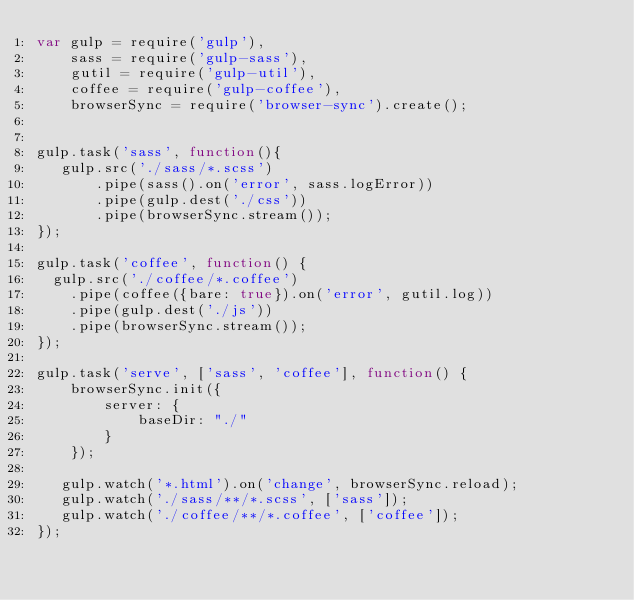<code> <loc_0><loc_0><loc_500><loc_500><_JavaScript_>var gulp = require('gulp'),
	sass = require('gulp-sass'),
	gutil = require('gulp-util'),
	coffee = require('gulp-coffee'),
	browserSync = require('browser-sync').create();


gulp.task('sass', function(){
   gulp.src('./sass/*.scss')
	   .pipe(sass().on('error', sass.logError))
	   .pipe(gulp.dest('./css'))
	   .pipe(browserSync.stream());
});

gulp.task('coffee', function() {
  gulp.src('./coffee/*.coffee')
    .pipe(coffee({bare: true}).on('error', gutil.log))
    .pipe(gulp.dest('./js'))
	.pipe(browserSync.stream());
});

gulp.task('serve', ['sass', 'coffee'], function() {
	browserSync.init({
		server: {
			baseDir: "./"
		}
	});

   gulp.watch('*.html').on('change', browserSync.reload);
   gulp.watch('./sass/**/*.scss', ['sass']);
   gulp.watch('./coffee/**/*.coffee', ['coffee']);
});
</code> 